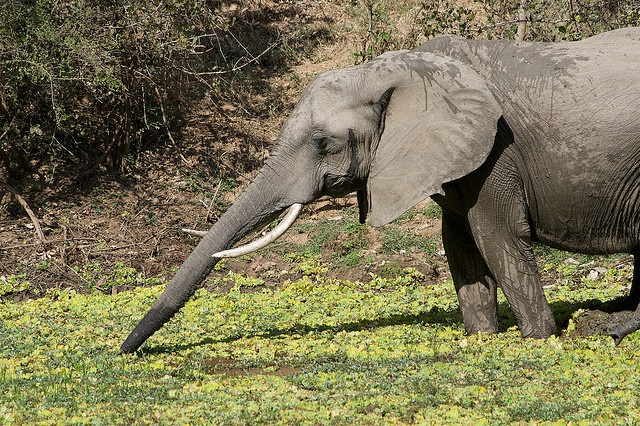Describe the objects in this image and their specific colors. I can see a elephant in gray, darkgray, and black tones in this image. 